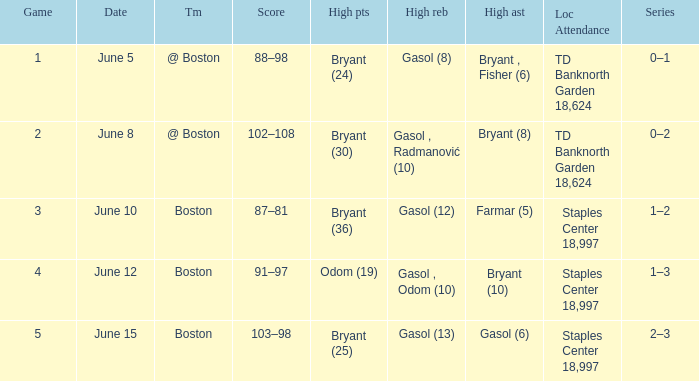Name the series on june 5 0–1. 